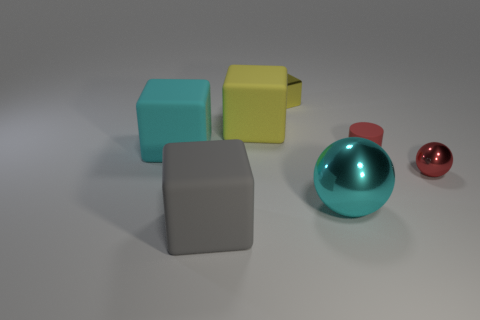Subtract all small metal blocks. How many blocks are left? 3 Add 3 cyan matte blocks. How many objects exist? 10 Subtract all cubes. How many objects are left? 3 Subtract all cyan cubes. How many cubes are left? 3 Subtract 0 gray spheres. How many objects are left? 7 Subtract 2 balls. How many balls are left? 0 Subtract all yellow balls. Subtract all yellow cylinders. How many balls are left? 2 Subtract all purple cubes. How many cyan cylinders are left? 0 Subtract all yellow rubber cylinders. Subtract all large gray blocks. How many objects are left? 6 Add 7 yellow metallic things. How many yellow metallic things are left? 8 